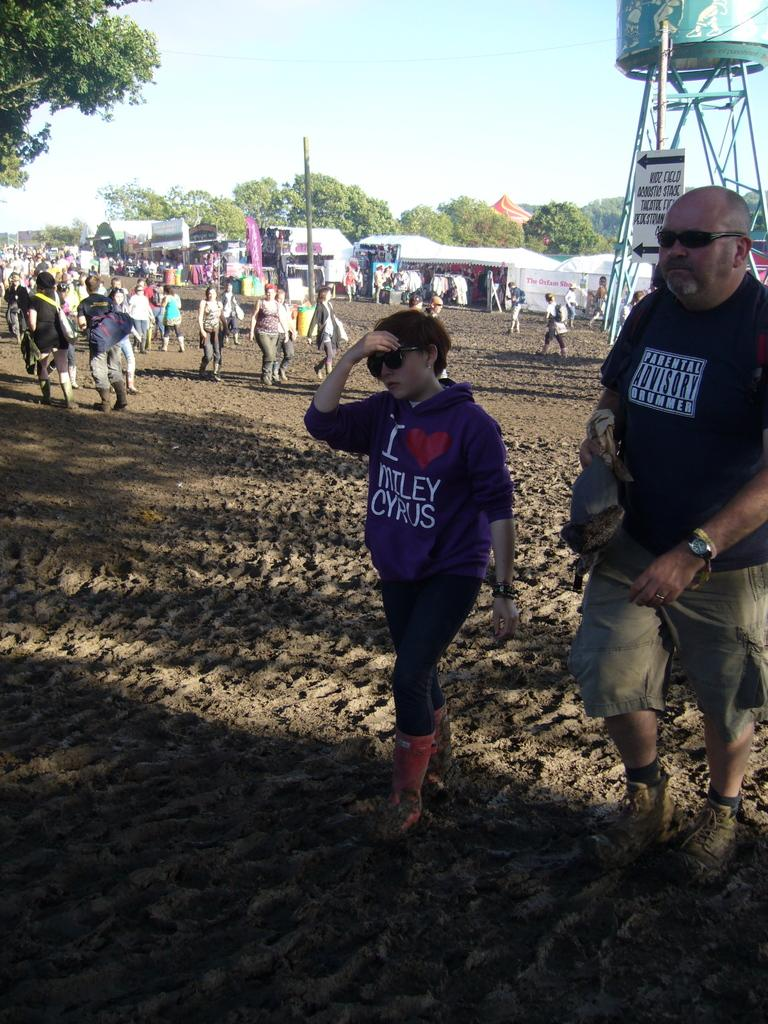What are the people in the image doing? The people in the image are walking. On what surface are the people walking? The people are walking on sand land. What can be seen in the background of the image? In the background of the image, there is a water tank, tents, trees, and the sky. Can you see a cat performing a circle on a skate in the image? No, there is no cat or skate present in the image. 